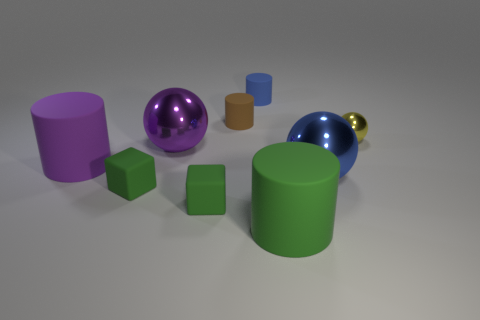Subtract all big green cylinders. How many cylinders are left? 3 Subtract 4 cylinders. How many cylinders are left? 0 Subtract all blocks. How many objects are left? 7 Subtract all small cubes. Subtract all green cylinders. How many objects are left? 6 Add 9 big blue shiny spheres. How many big blue shiny spheres are left? 10 Add 7 tiny blue matte cylinders. How many tiny blue matte cylinders exist? 8 Add 1 purple things. How many objects exist? 10 Subtract all blue balls. How many balls are left? 2 Subtract 0 red blocks. How many objects are left? 9 Subtract all brown cubes. Subtract all cyan balls. How many cubes are left? 2 